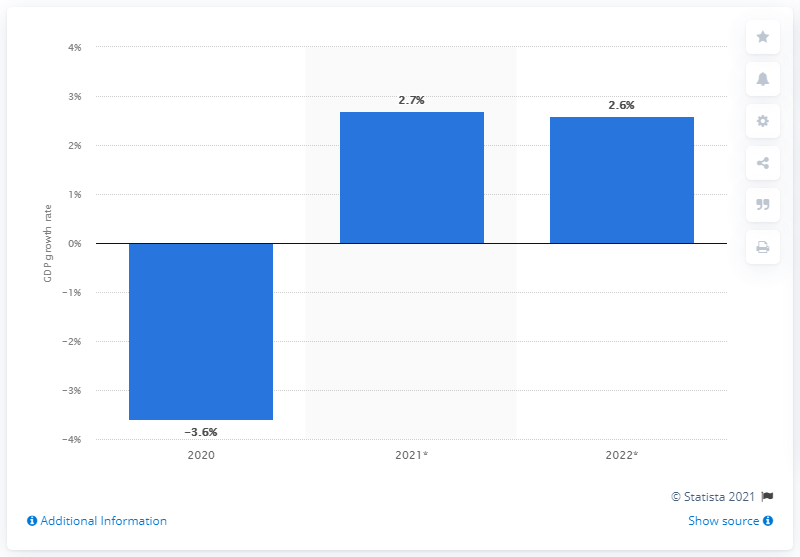Identify some key points in this picture. The forecast for Russia's real GDP in 2021 was 2.7. 